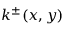<formula> <loc_0><loc_0><loc_500><loc_500>k ^ { \pm } ( x , y )</formula> 